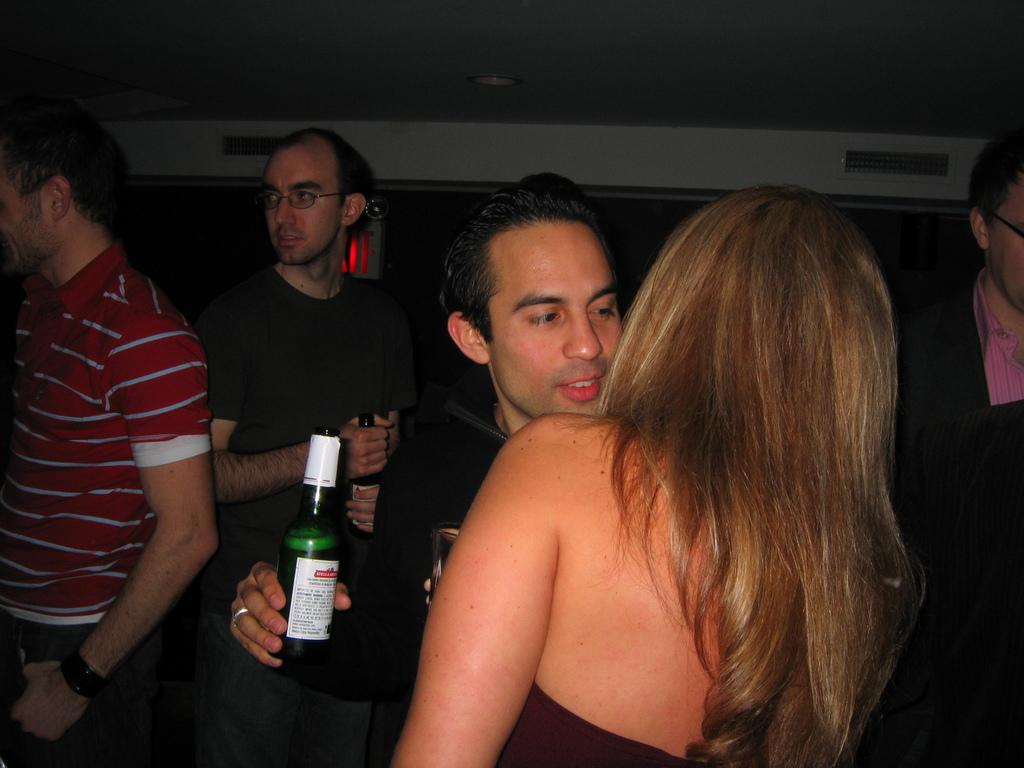What is happening in the image? There are people standing in the image. What are some of the people holding? Some of the people are holding bottles. What is the angle of the voyage in the image? There is no voyage present in the image, so it is not possible to determine the angle of a voyage. 